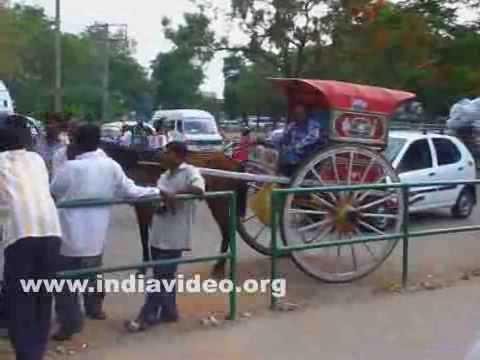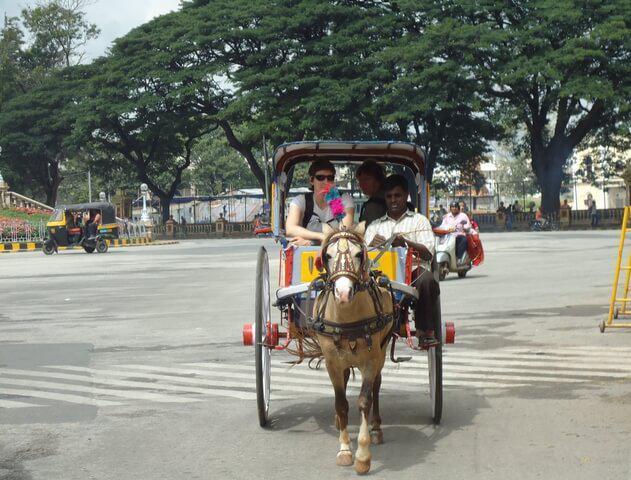The first image is the image on the left, the second image is the image on the right. For the images shown, is this caption "The cart in one of the images is red." true? Answer yes or no. Yes. 